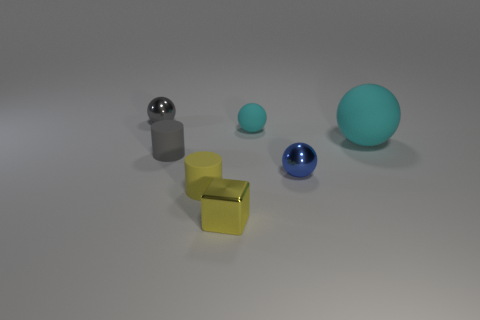Subtract all small gray balls. How many balls are left? 3 Add 2 big green matte balls. How many objects exist? 9 Subtract all blue spheres. How many spheres are left? 3 Subtract all brown cylinders. How many cyan spheres are left? 2 Subtract all cubes. How many objects are left? 6 Subtract 3 balls. How many balls are left? 1 Add 2 gray objects. How many gray objects are left? 4 Add 7 tiny yellow cylinders. How many tiny yellow cylinders exist? 8 Subtract 0 brown cubes. How many objects are left? 7 Subtract all blue balls. Subtract all brown cylinders. How many balls are left? 3 